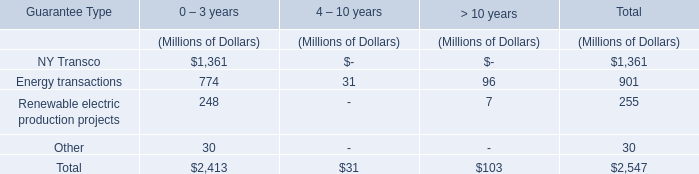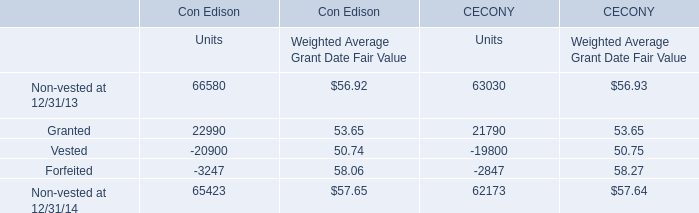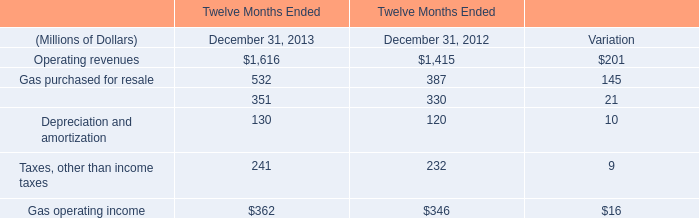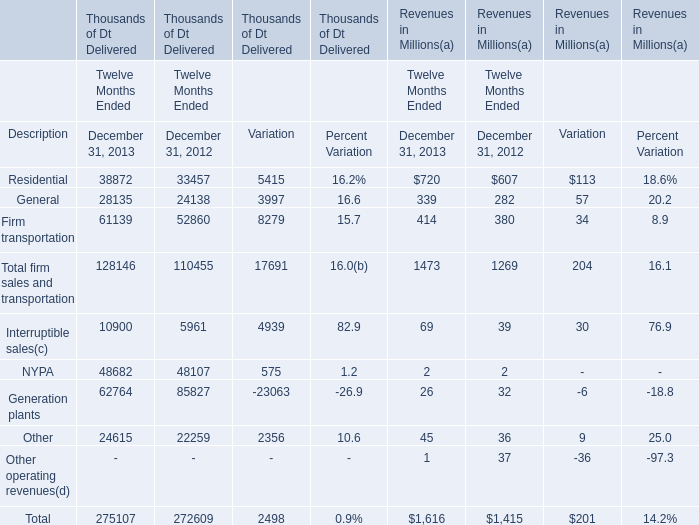What is the sum of the Gas purchased for resale in the years where Operating revenuesis positive? (in million) 
Computations: (532 + 387)
Answer: 919.0. 